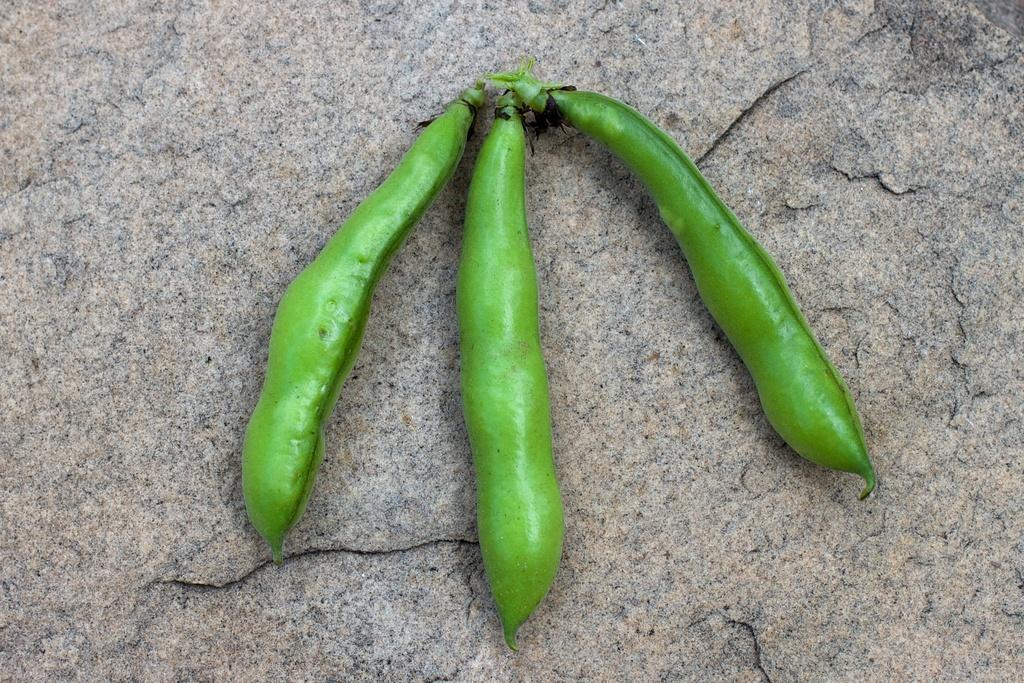Could you give a brief overview of what you see in this image? In this picture we can see three green peas placed on a rock platform. 